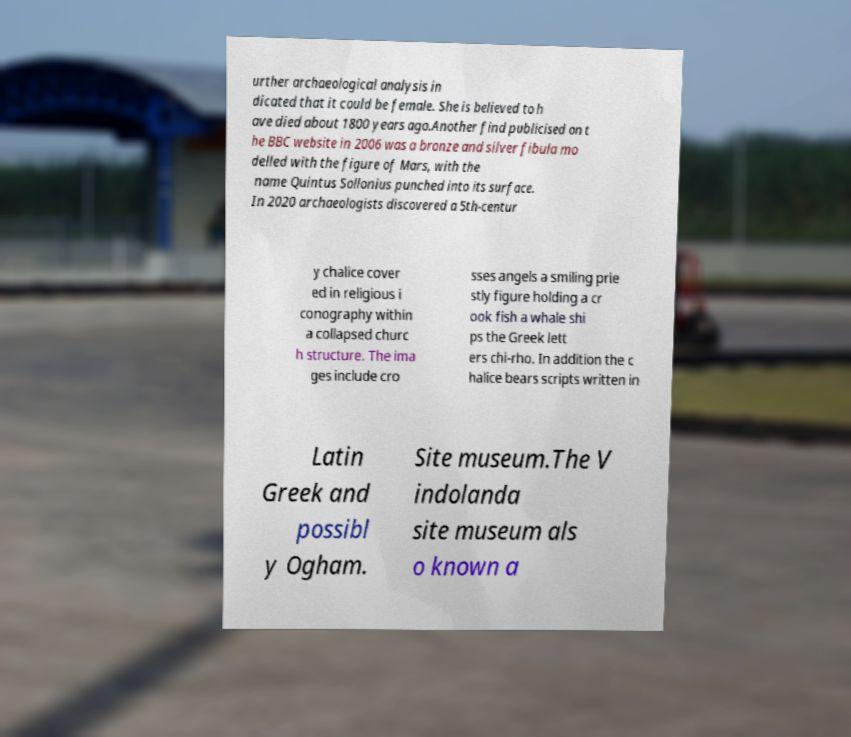There's text embedded in this image that I need extracted. Can you transcribe it verbatim? urther archaeological analysis in dicated that it could be female. She is believed to h ave died about 1800 years ago.Another find publicised on t he BBC website in 2006 was a bronze and silver fibula mo delled with the figure of Mars, with the name Quintus Sollonius punched into its surface. In 2020 archaeologists discovered a 5th-centur y chalice cover ed in religious i conography within a collapsed churc h structure. The ima ges include cro sses angels a smiling prie stly figure holding a cr ook fish a whale shi ps the Greek lett ers chi-rho. In addition the c halice bears scripts written in Latin Greek and possibl y Ogham. Site museum.The V indolanda site museum als o known a 